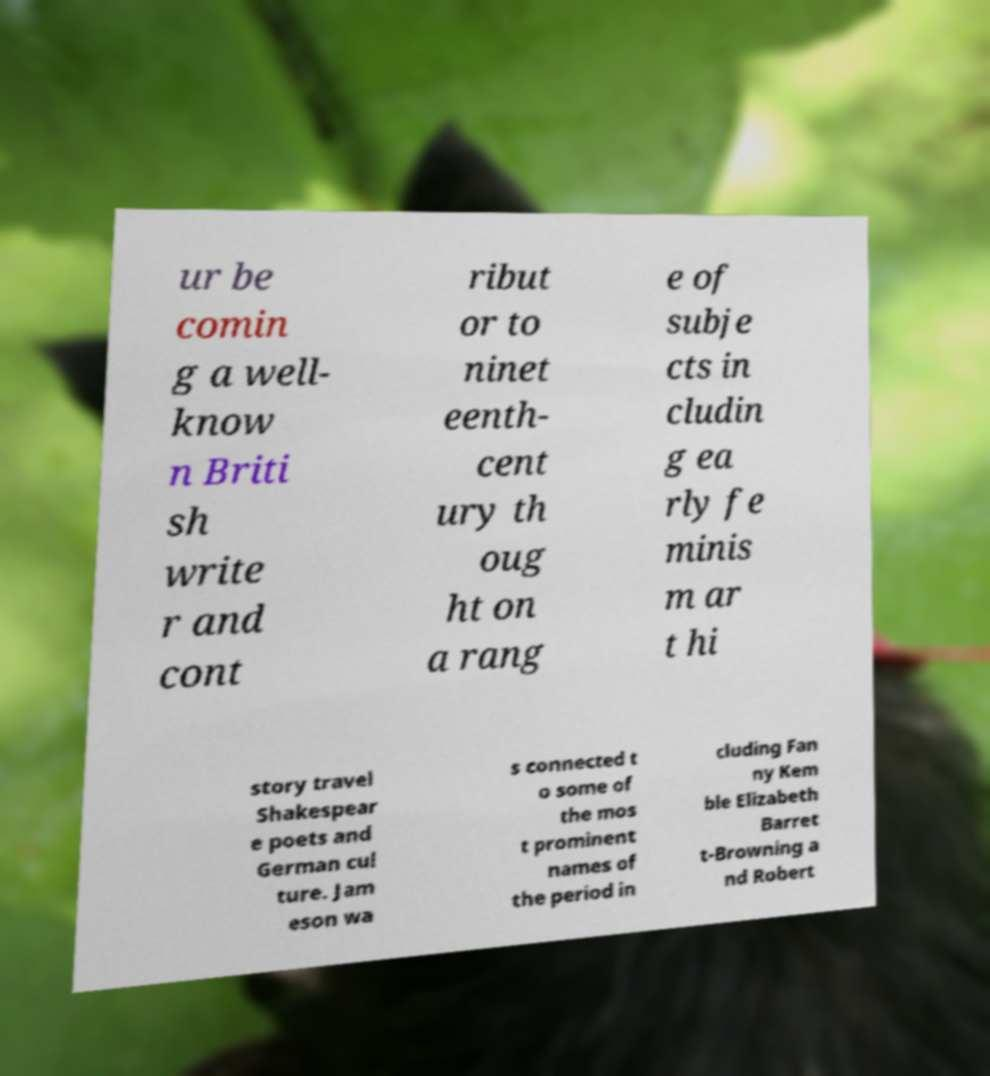What messages or text are displayed in this image? I need them in a readable, typed format. ur be comin g a well- know n Briti sh write r and cont ribut or to ninet eenth- cent ury th oug ht on a rang e of subje cts in cludin g ea rly fe minis m ar t hi story travel Shakespear e poets and German cul ture. Jam eson wa s connected t o some of the mos t prominent names of the period in cluding Fan ny Kem ble Elizabeth Barret t-Browning a nd Robert 